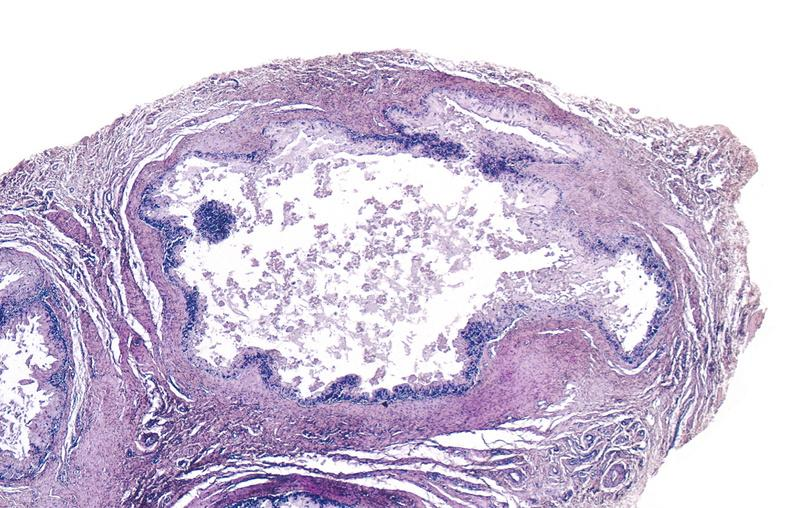what is present?
Answer the question using a single word or phrase. Joints 